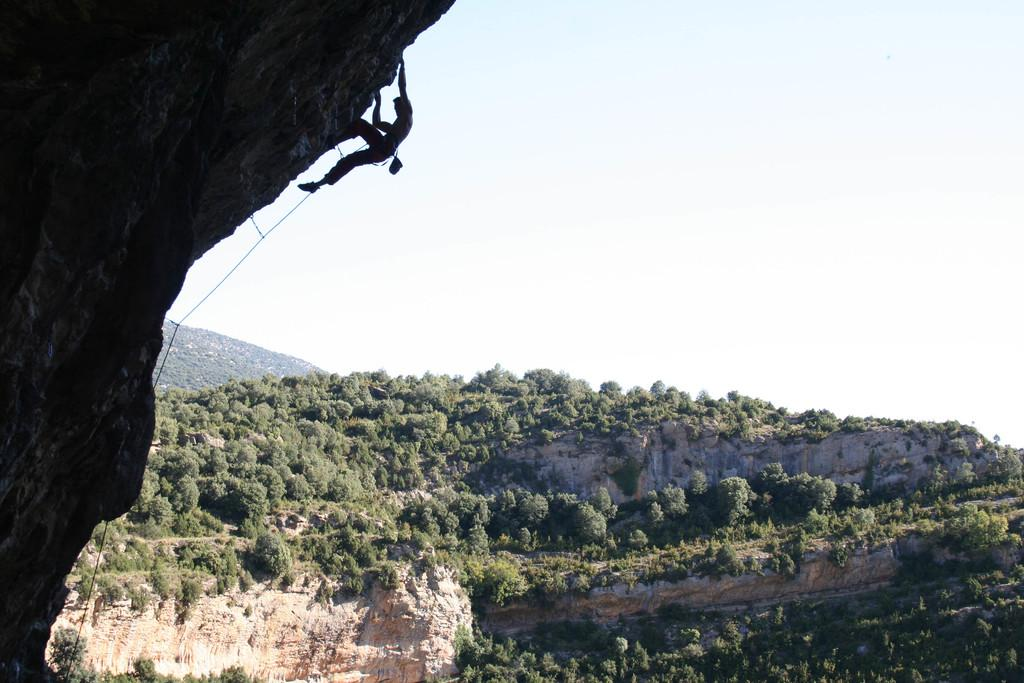Who is the main subject in the image? There is a man in the image. What is the man doing in the image? The man is climbing a mountain. How is the man assisted in his climb? The man is using a rope for assistance. What can be seen in the background of the image? There are trees, mountains, and the sky visible in the background of the image. Are there any bushes in the image that the man is trying to avoid? There is no mention of bushes in the image, so it cannot be determined if the man is trying to avoid them. Does the man express any feelings of hate towards the mountain while climbing? There is no indication of the man's emotions or feelings in the image, so it cannot be determined if he expresses any feelings of hate towards the mountain. 